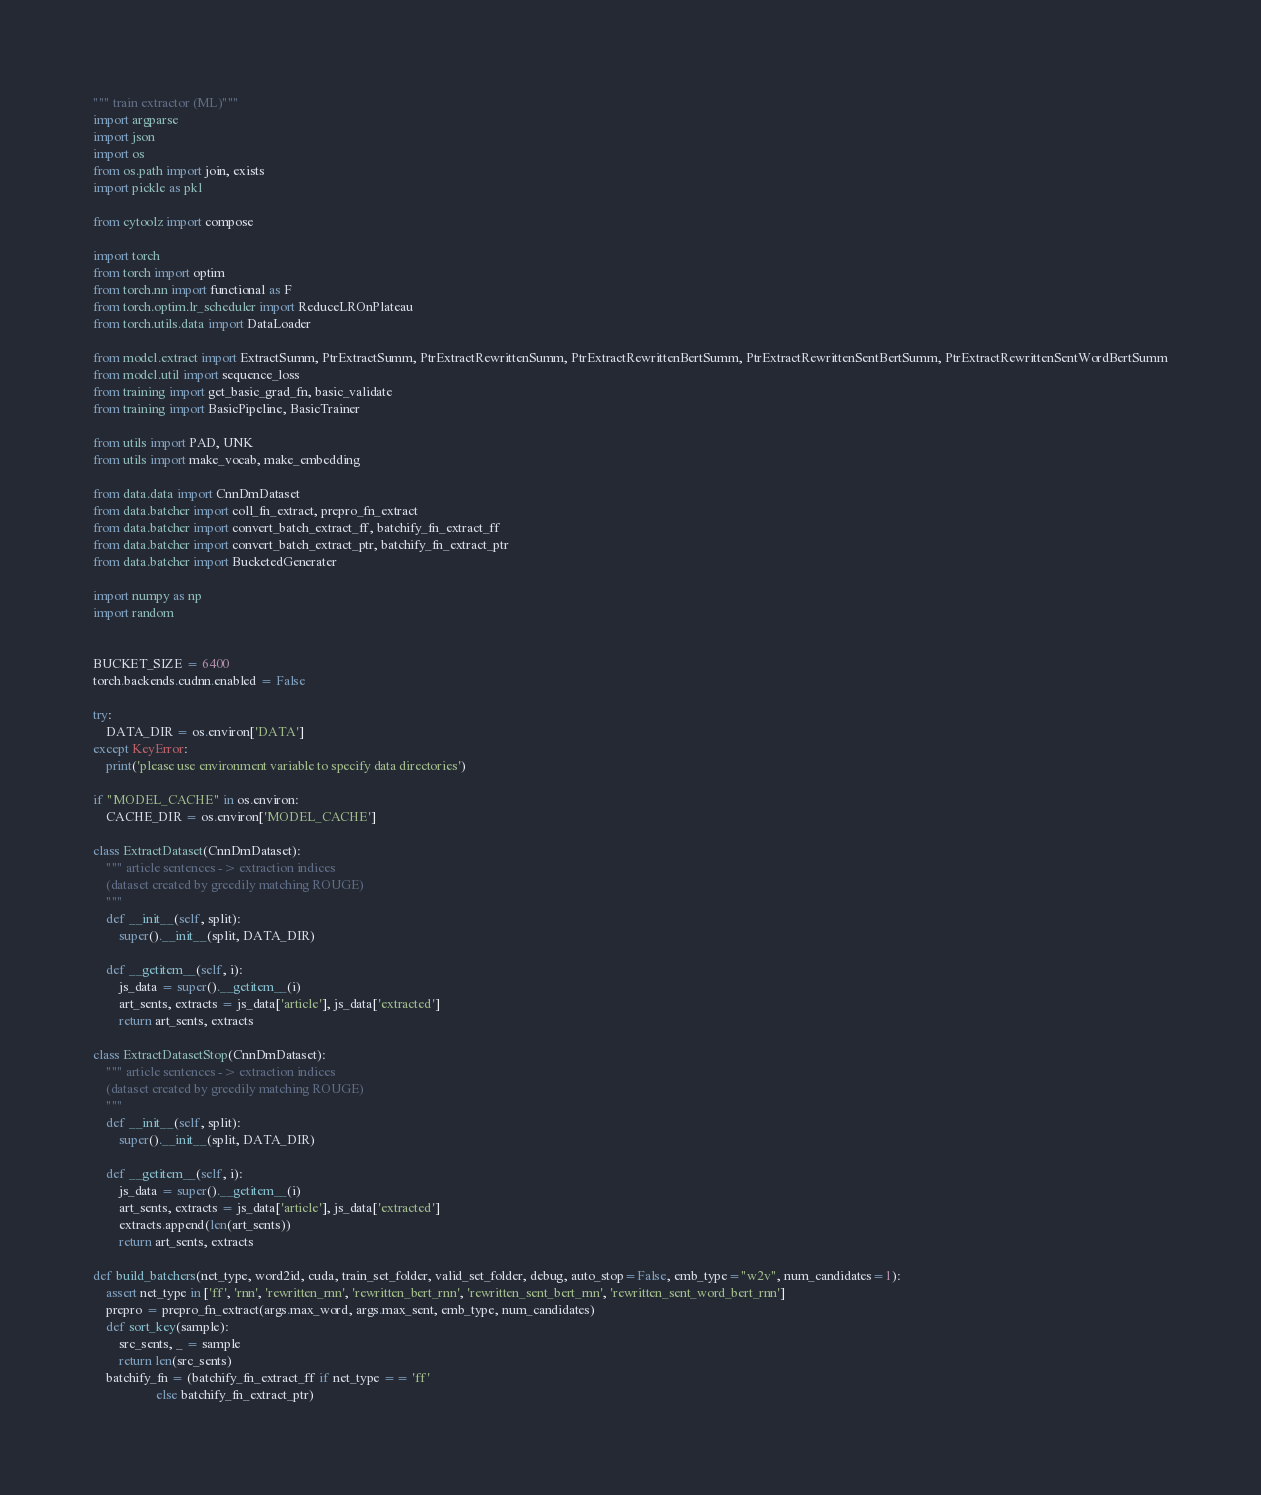<code> <loc_0><loc_0><loc_500><loc_500><_Python_>""" train extractor (ML)"""
import argparse
import json
import os
from os.path import join, exists
import pickle as pkl

from cytoolz import compose

import torch
from torch import optim
from torch.nn import functional as F
from torch.optim.lr_scheduler import ReduceLROnPlateau
from torch.utils.data import DataLoader

from model.extract import ExtractSumm, PtrExtractSumm, PtrExtractRewrittenSumm, PtrExtractRewrittenBertSumm, PtrExtractRewrittenSentBertSumm, PtrExtractRewrittenSentWordBertSumm
from model.util import sequence_loss
from training import get_basic_grad_fn, basic_validate
from training import BasicPipeline, BasicTrainer

from utils import PAD, UNK
from utils import make_vocab, make_embedding

from data.data import CnnDmDataset
from data.batcher import coll_fn_extract, prepro_fn_extract
from data.batcher import convert_batch_extract_ff, batchify_fn_extract_ff
from data.batcher import convert_batch_extract_ptr, batchify_fn_extract_ptr
from data.batcher import BucketedGenerater

import numpy as np
import random


BUCKET_SIZE = 6400
torch.backends.cudnn.enabled = False

try:
    DATA_DIR = os.environ['DATA']
except KeyError:
    print('please use environment variable to specify data directories')

if "MODEL_CACHE" in os.environ:
    CACHE_DIR = os.environ['MODEL_CACHE']

class ExtractDataset(CnnDmDataset):
    """ article sentences -> extraction indices
    (dataset created by greedily matching ROUGE)
    """
    def __init__(self, split):
        super().__init__(split, DATA_DIR)

    def __getitem__(self, i):
        js_data = super().__getitem__(i)
        art_sents, extracts = js_data['article'], js_data['extracted']
        return art_sents, extracts

class ExtractDatasetStop(CnnDmDataset):
    """ article sentences -> extraction indices
    (dataset created by greedily matching ROUGE)
    """
    def __init__(self, split):
        super().__init__(split, DATA_DIR)

    def __getitem__(self, i):
        js_data = super().__getitem__(i)
        art_sents, extracts = js_data['article'], js_data['extracted']
        extracts.append(len(art_sents))
        return art_sents, extracts

def build_batchers(net_type, word2id, cuda, train_set_folder, valid_set_folder, debug, auto_stop=False, emb_type="w2v", num_candidates=1):
    assert net_type in ['ff', 'rnn', 'rewritten_rnn', 'rewritten_bert_rnn', 'rewritten_sent_bert_rnn', 'rewritten_sent_word_bert_rnn']
    prepro = prepro_fn_extract(args.max_word, args.max_sent, emb_type, num_candidates)
    def sort_key(sample):
        src_sents, _ = sample
        return len(src_sents)
    batchify_fn = (batchify_fn_extract_ff if net_type == 'ff'
                   else batchify_fn_extract_ptr)</code> 